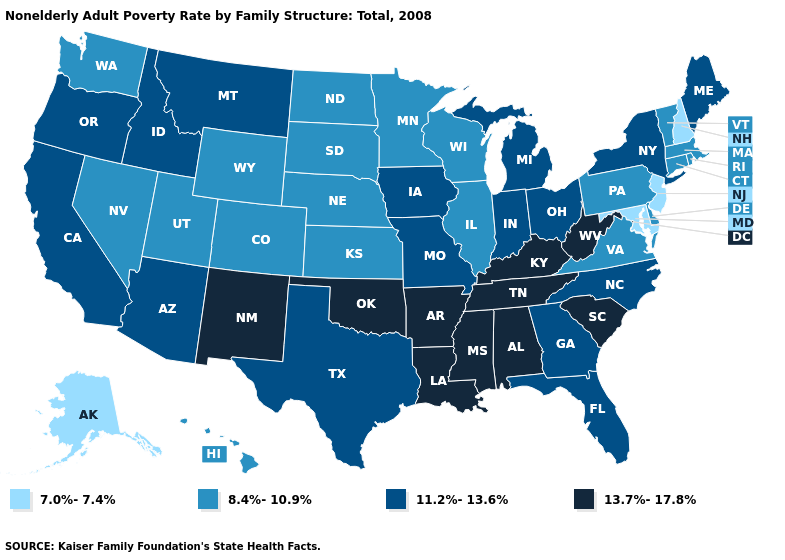Does West Virginia have the highest value in the USA?
Quick response, please. Yes. Name the states that have a value in the range 11.2%-13.6%?
Quick response, please. Arizona, California, Florida, Georgia, Idaho, Indiana, Iowa, Maine, Michigan, Missouri, Montana, New York, North Carolina, Ohio, Oregon, Texas. What is the highest value in states that border Idaho?
Be succinct. 11.2%-13.6%. What is the value of West Virginia?
Give a very brief answer. 13.7%-17.8%. What is the lowest value in the Northeast?
Give a very brief answer. 7.0%-7.4%. What is the value of Wisconsin?
Quick response, please. 8.4%-10.9%. Name the states that have a value in the range 7.0%-7.4%?
Quick response, please. Alaska, Maryland, New Hampshire, New Jersey. How many symbols are there in the legend?
Short answer required. 4. Name the states that have a value in the range 13.7%-17.8%?
Short answer required. Alabama, Arkansas, Kentucky, Louisiana, Mississippi, New Mexico, Oklahoma, South Carolina, Tennessee, West Virginia. Does Virginia have the lowest value in the USA?
Write a very short answer. No. Among the states that border Idaho , does Oregon have the lowest value?
Be succinct. No. Does South Carolina have the highest value in the USA?
Be succinct. Yes. Among the states that border Mississippi , which have the highest value?
Give a very brief answer. Alabama, Arkansas, Louisiana, Tennessee. 